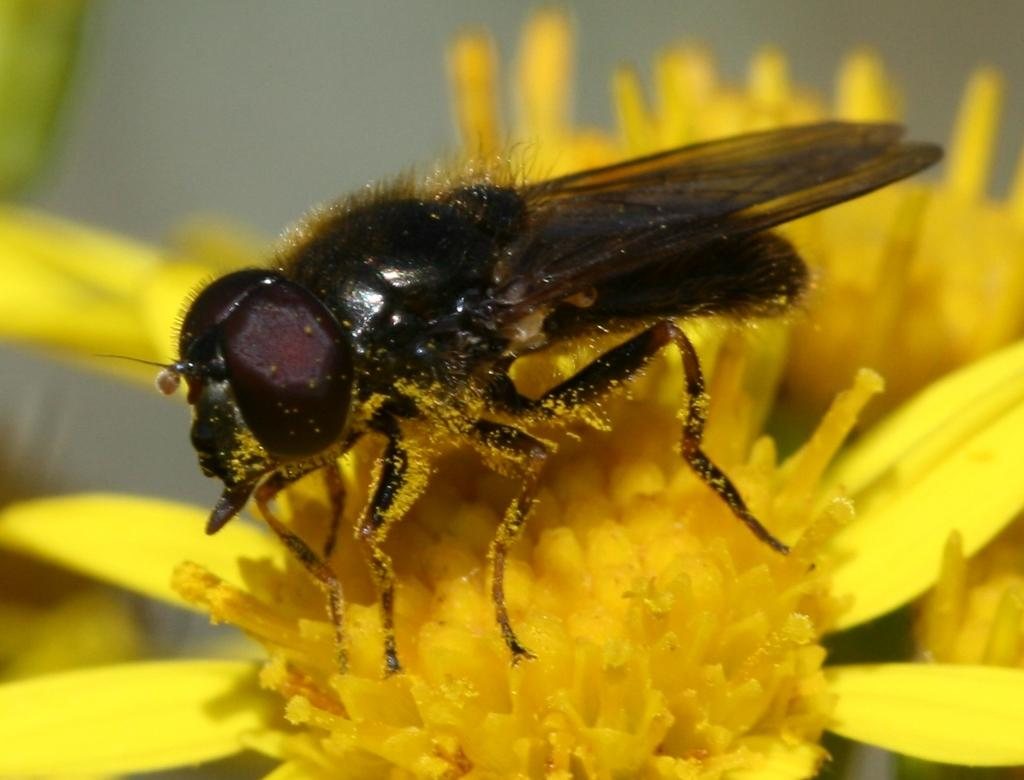What is present on the flower in the image? There is a fly on the flower in the image. Can you describe the color of the flower? The flower is yellow. What type of yak can be seen grazing on the flower in the image? There is no yak present in the image; it only features a fly on a yellow flower. 